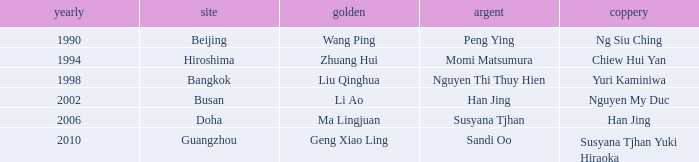What's the Bronze with the Year of 1998? Yuri Kaminiwa. 